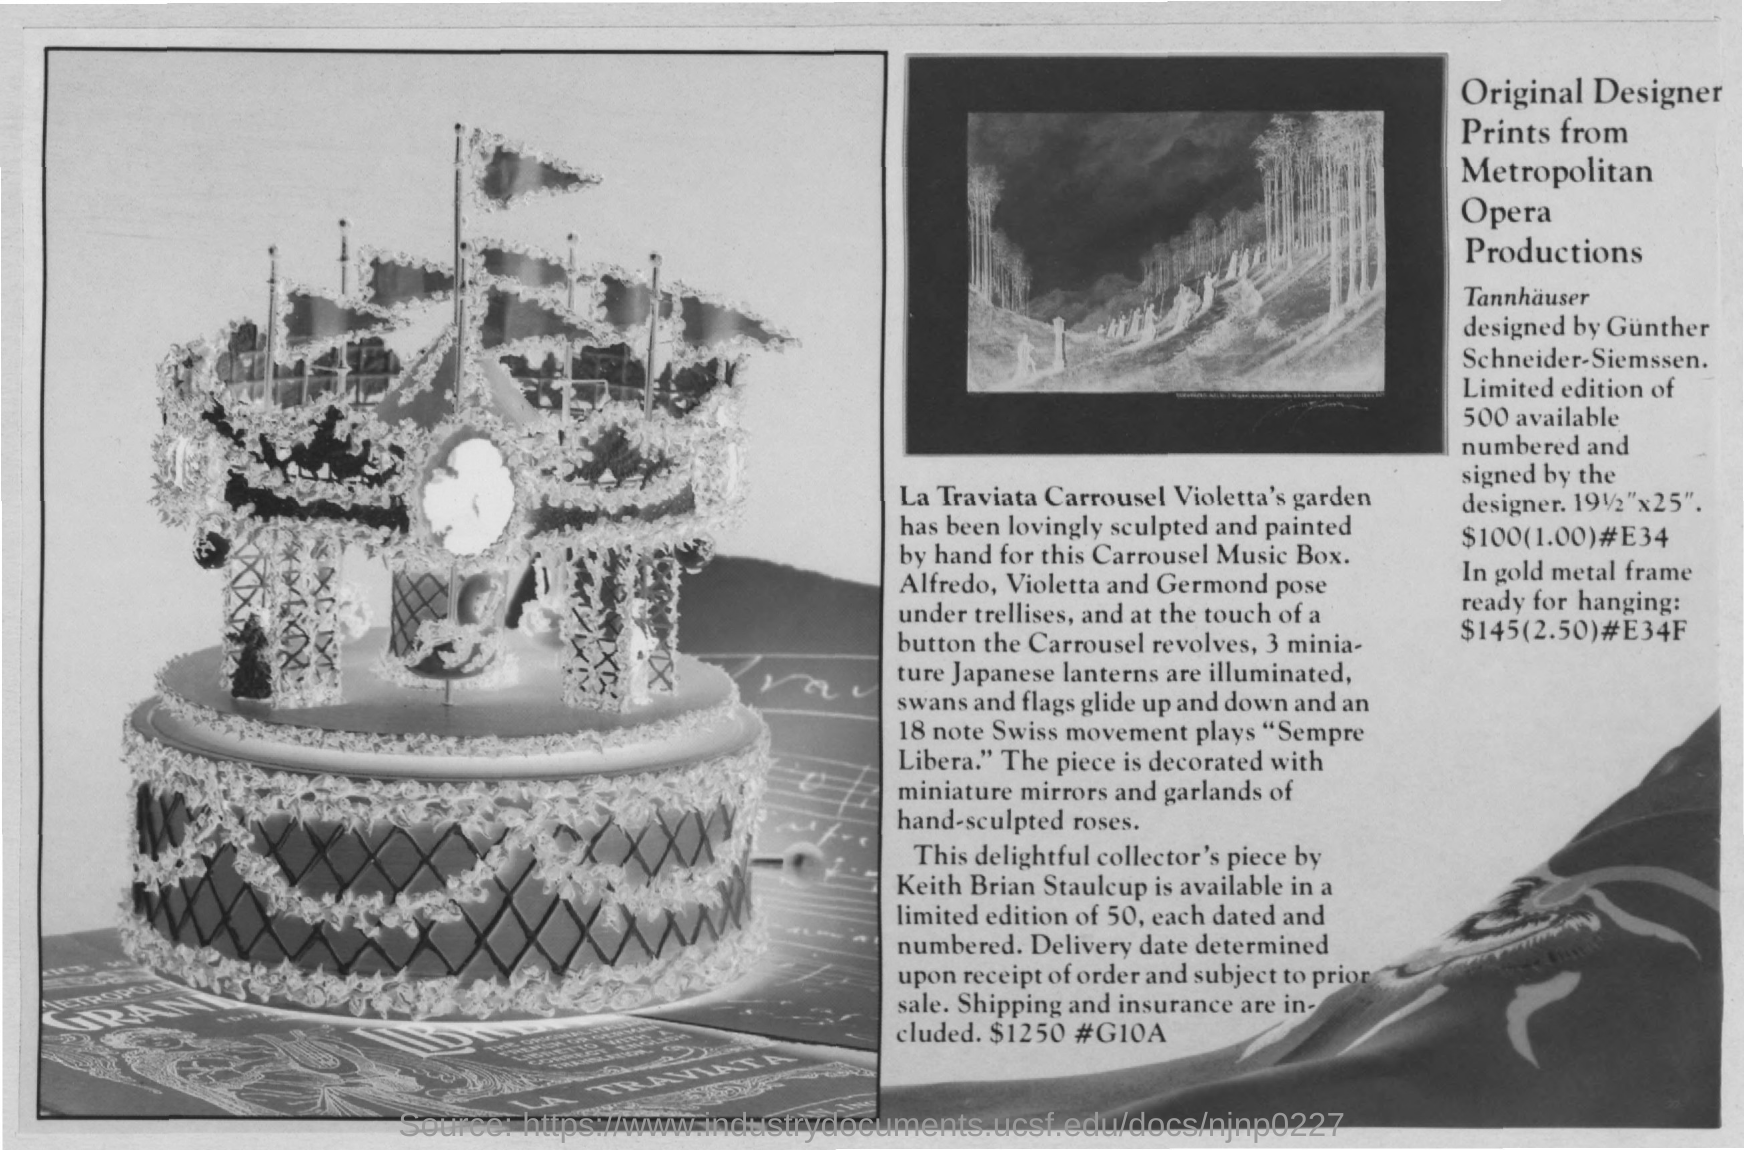Outline some significant characteristics in this image. There were 500 pieces of Original Designer Print available from Metropolitan Opera Productions. Gunther Schneider-Siemssen designed Tannhauser. The music box features a sculpted and painted depiction of Violetta's Garden. 